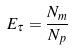Convert formula to latex. <formula><loc_0><loc_0><loc_500><loc_500>E _ { \tau } = \frac { N _ { m } } { N _ { p } }</formula> 